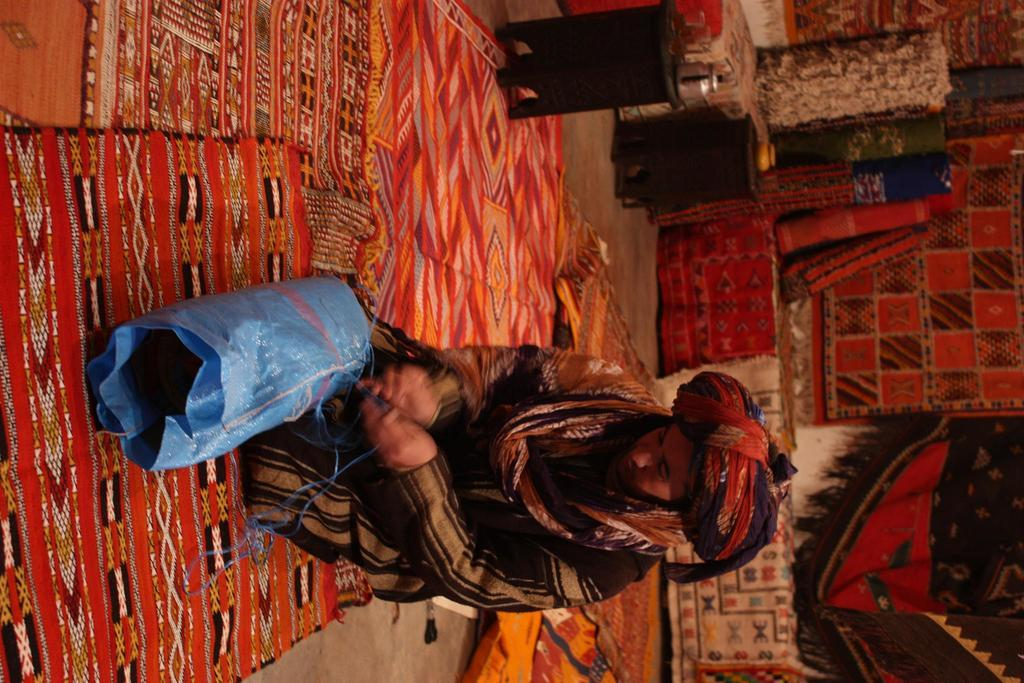Who or what is present in the image? There is a person in the image. What is the person wearing? The person is wearing a black and brown color dress. What type of flooring can be seen in the image? There are multicolored carpets in the image. What month does the wren fly through the hole in the image? There is no wren or hole present in the image, so this question cannot be answered. 